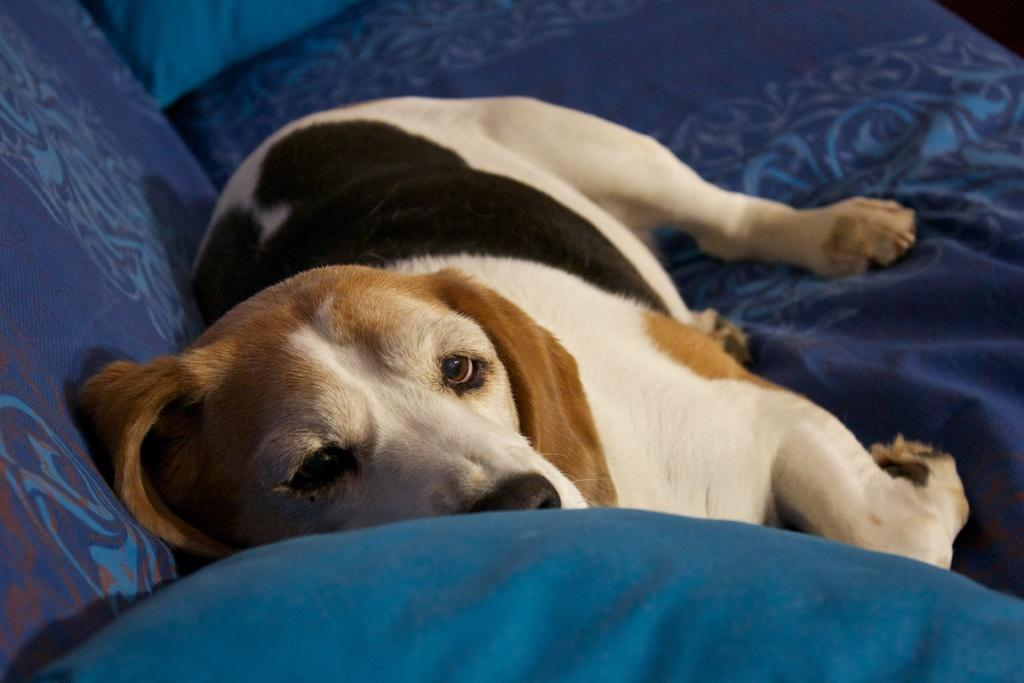What type of animal is in the image? There is a dog in the image. What colors can be seen on the dog? The dog has white, cream, and black colors. Where is the dog located in the image? The dog is on a couch. What color is the couch? The couch is blue. Can you see the dog using a mark to draw on the couch? There is no mark or drawing activity present in the image; it simply shows a dog on a blue couch. 